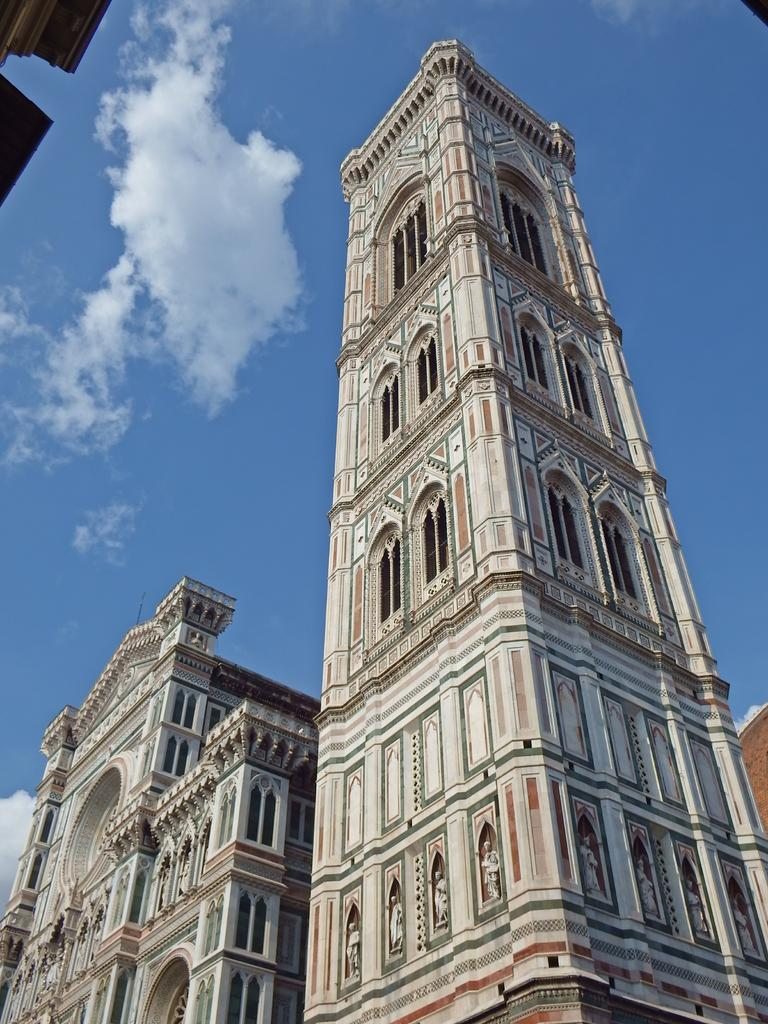What type of view is shown in the image? The image is an outside view. What structures can be seen in the image? There are buildings in the image. What feature do the buildings have? The buildings have windows. What is visible at the top of the image? The sky is visible at the top of the image. What can be observed in the sky? Clouds are present in the sky. What color is the pear hanging from the wrist of the person in the image? There is no person or pear present in the image. 